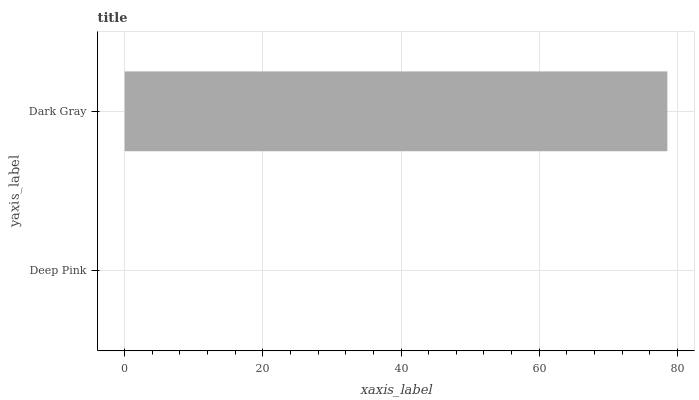Is Deep Pink the minimum?
Answer yes or no. Yes. Is Dark Gray the maximum?
Answer yes or no. Yes. Is Dark Gray the minimum?
Answer yes or no. No. Is Dark Gray greater than Deep Pink?
Answer yes or no. Yes. Is Deep Pink less than Dark Gray?
Answer yes or no. Yes. Is Deep Pink greater than Dark Gray?
Answer yes or no. No. Is Dark Gray less than Deep Pink?
Answer yes or no. No. Is Dark Gray the high median?
Answer yes or no. Yes. Is Deep Pink the low median?
Answer yes or no. Yes. Is Deep Pink the high median?
Answer yes or no. No. Is Dark Gray the low median?
Answer yes or no. No. 